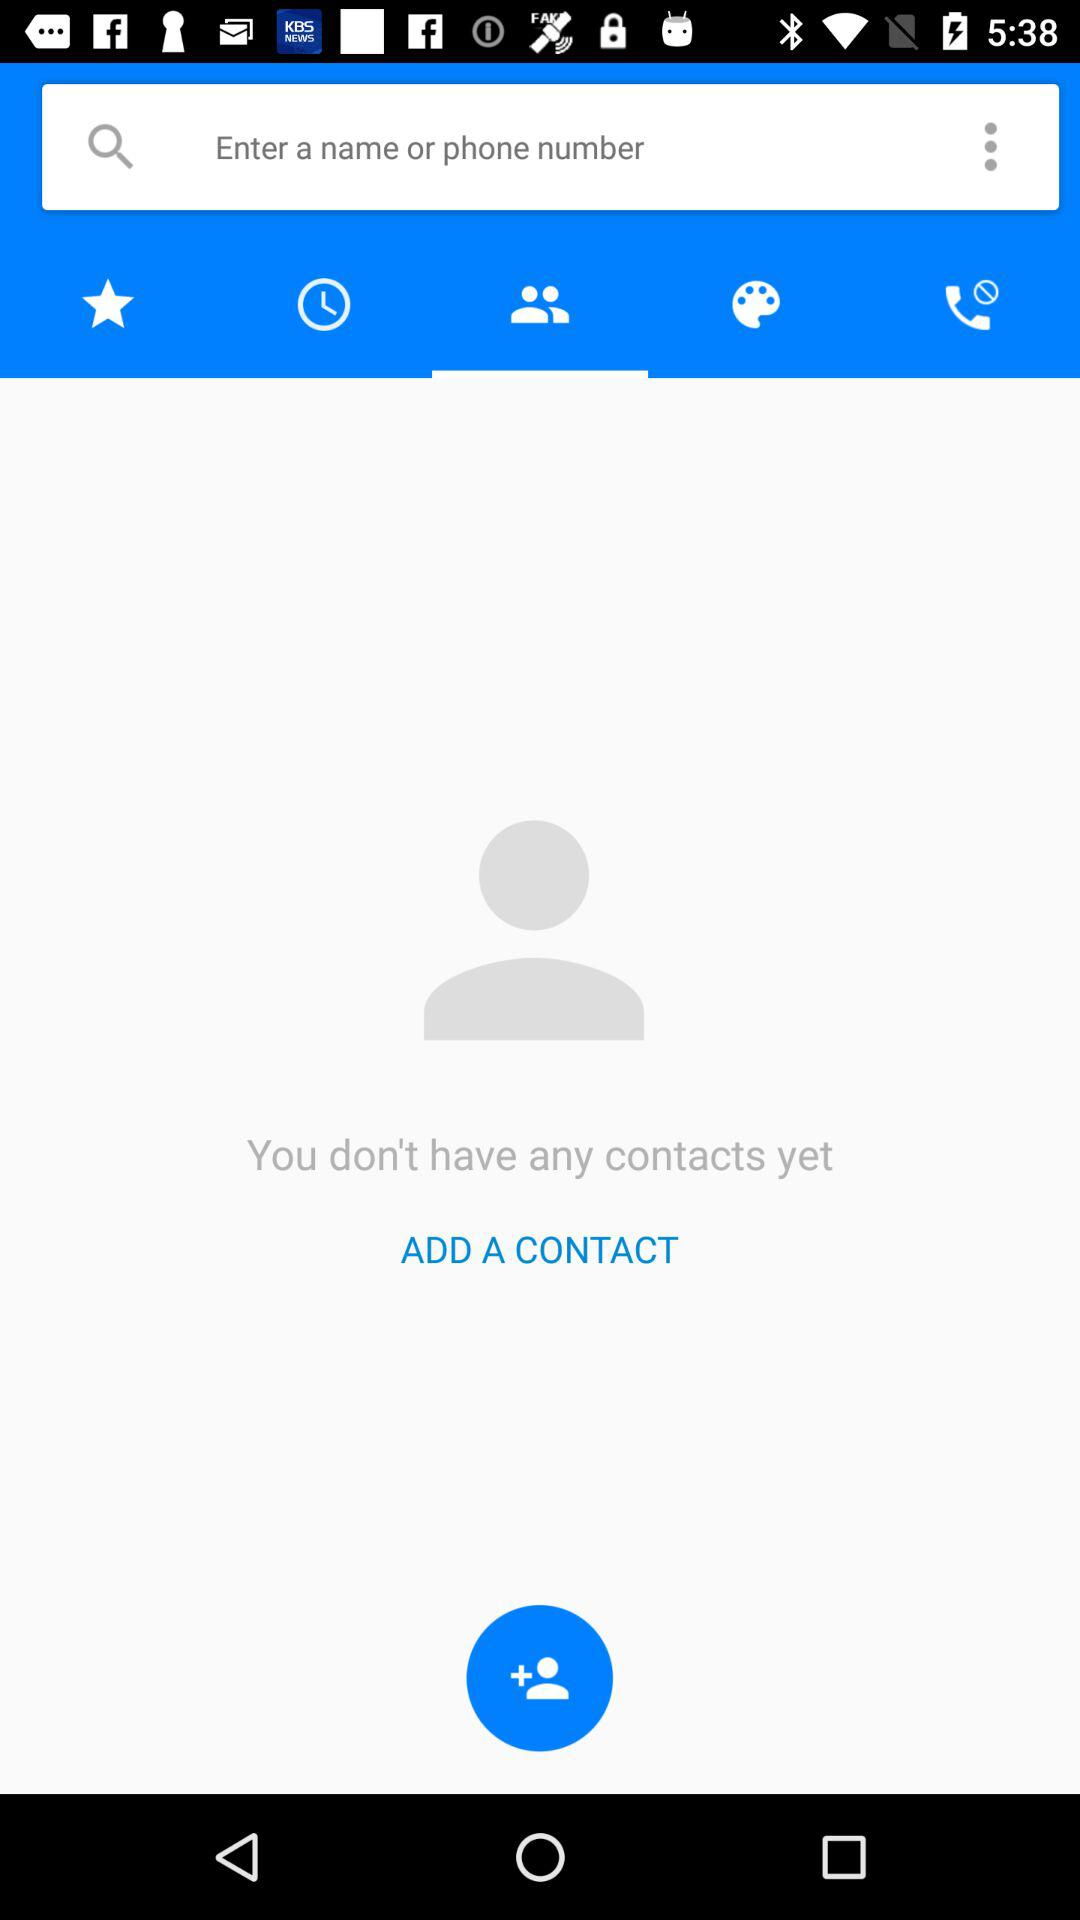How many contacts do I have?
Answer the question using a single word or phrase. 0 